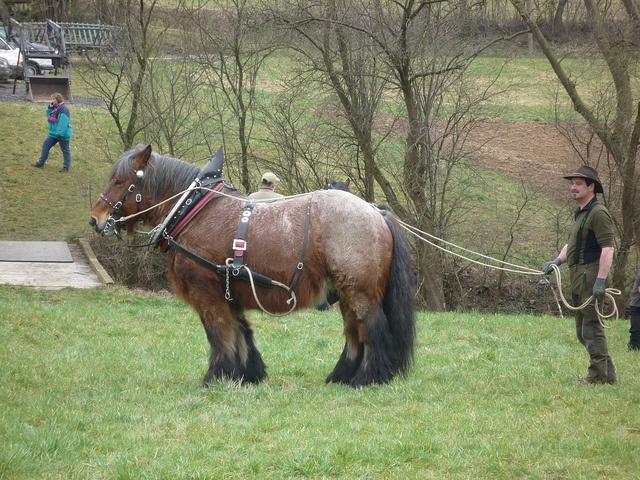Describe the objects in this image and their specific colors. I can see horse in gray, black, darkgray, and maroon tones, people in gray and black tones, people in gray, blue, teal, and navy tones, car in gray, white, darkgray, and black tones, and people in gray, lightgray, and darkgray tones in this image. 